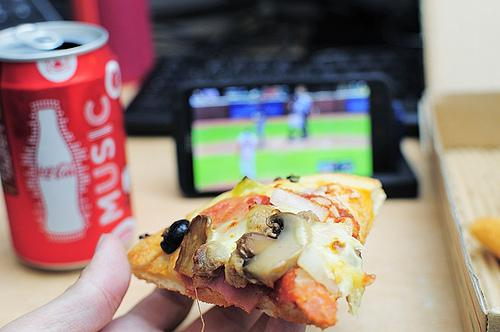Question: where is the pizza box?
Choices:
A. To the right.
B. To the left.
C. At the top.
D. At the bottom.
Answer with the letter. Answer: A Question: who owns the soda company?
Choices:
A. Pepsi.
B. Nabisco.
C. Gm.
D. Coca-cola.
Answer with the letter. Answer: D Question: what sport is playing on the phone?
Choices:
A. Soccer.
B. Baseball.
C. Football.
D. Rugby.
Answer with the letter. Answer: B Question: what is the person watching baseball on?
Choices:
A. Tablet.
B. Phone.
C. Laptop.
D. Desktop.
Answer with the letter. Answer: B Question: what vegetables are on the pizza?
Choices:
A. Olives and artichokes.
B. Mushroom and pickles.
C. Pickles and olives.
D. Mushroom and olives.
Answer with the letter. Answer: D 